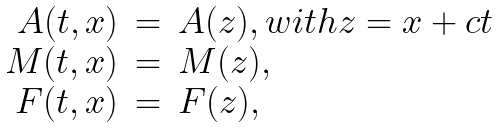<formula> <loc_0><loc_0><loc_500><loc_500>\begin{array} { r c l } A ( t , x ) & = & A ( z ) , w i t h z = x + c t \\ M ( t , x ) & = & M ( z ) , \\ F ( t , x ) & = & F ( z ) , \end{array}</formula> 